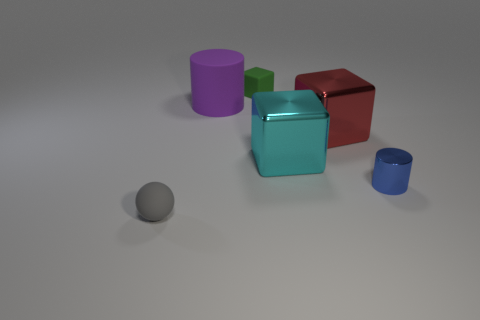Subtract all large red metallic cubes. How many cubes are left? 2 Add 3 blocks. How many objects exist? 9 Subtract all purple cylinders. How many cylinders are left? 1 Subtract 3 cubes. How many cubes are left? 0 Subtract all small green objects. Subtract all tiny matte things. How many objects are left? 3 Add 2 cyan objects. How many cyan objects are left? 3 Add 3 blue cylinders. How many blue cylinders exist? 4 Subtract 0 yellow blocks. How many objects are left? 6 Subtract all spheres. How many objects are left? 5 Subtract all blue blocks. Subtract all yellow cylinders. How many blocks are left? 3 